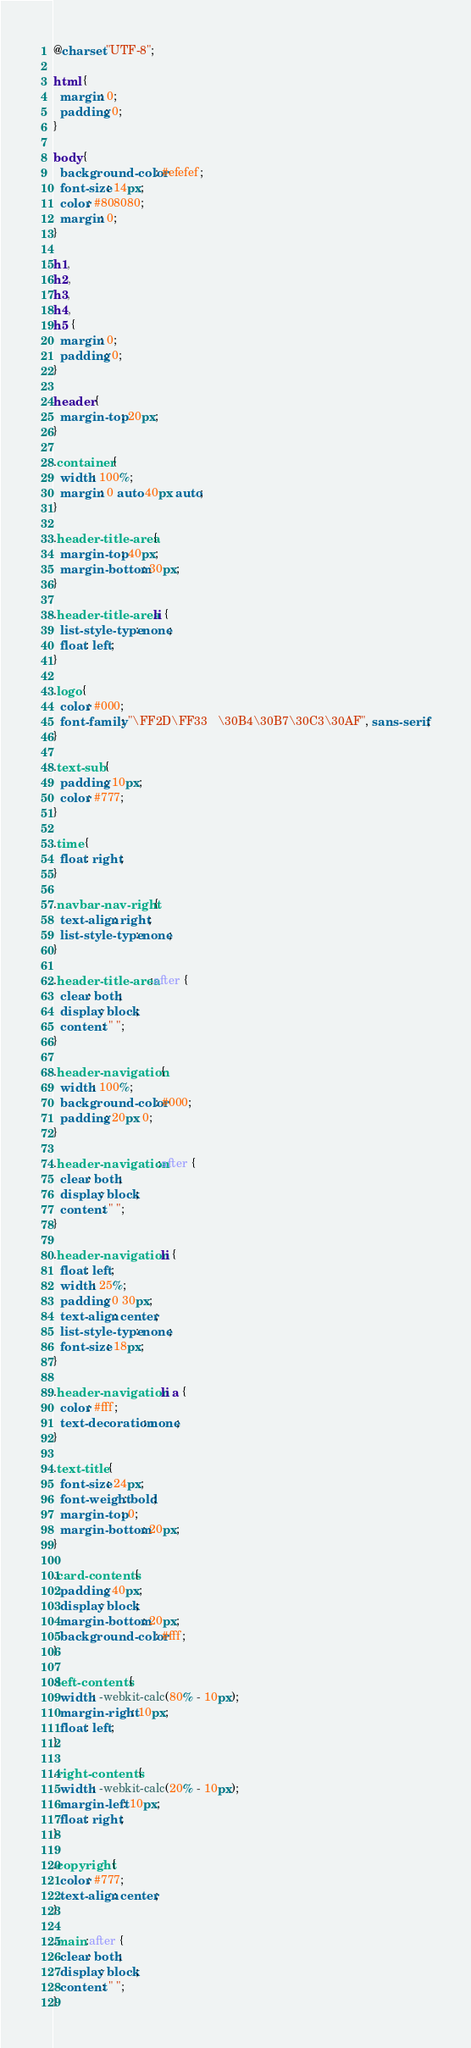<code> <loc_0><loc_0><loc_500><loc_500><_CSS_>@charset "UTF-8";

html {
  margin: 0;
  padding: 0;
}

body {
  background-color: #efefef;
  font-size: 14px;
  color: #808080;
  margin: 0;
}

h1,
h2,
h3,
h4,
h5 {
  margin: 0;
  padding: 0;
}

header {
  margin-top: 20px;
}

.container {
  width: 100%;
  margin: 0 auto 40px auto;
}

.header-title-area {
  margin-top: 40px;
  margin-bottom: 30px;
}

.header-title-area li {
  list-style-type: none;
  float: left;
}

.logo {
  color: #000;
  font-family: "\FF2D\FF33   \30B4\30B7\30C3\30AF", sans-serif;
}

.text-sub {
  padding: 10px;
  color: #777;
}

.time {
  float: right;
}

.navbar-nav-right {
  text-align: right;
  list-style-type: none;
}

.header-title-area:after {
  clear: both;
  display: block;
  content: " ";
}

.header-navigation {
  width: 100%;
  background-color: #000;
  padding: 20px 0;
}

.header-navigation:after {
  clear: both;
  display: block;
  content: " ";
}

.header-navigation li {
  float: left;
  width: 25%;
  padding: 0 30px;
  text-align: center;
  list-style-type: none;
  font-size: 18px;
}

.header-navigation li a {
  color: #fff;
  text-decoration: none;
}

.text-title {
  font-size: 24px;
  font-weight: bold;
  margin-top: 0;
  margin-bottom: 20px;
}

.card-contents {
  padding: 40px;
  display: block;
  margin-bottom: 20px;
  background-color: #fff;
}

.left-contents {
  width: -webkit-calc(80% - 10px);
  margin-right: 10px;
  float: left;
}

.right-contents {
  width: -webkit-calc(20% - 10px);
  margin-left: 10px;
  float: right;
}

.copyright {
  color: #777;
  text-align: center;
}

.main:after {
  clear: both;
  display: block;
  content: " ";
}

</code> 